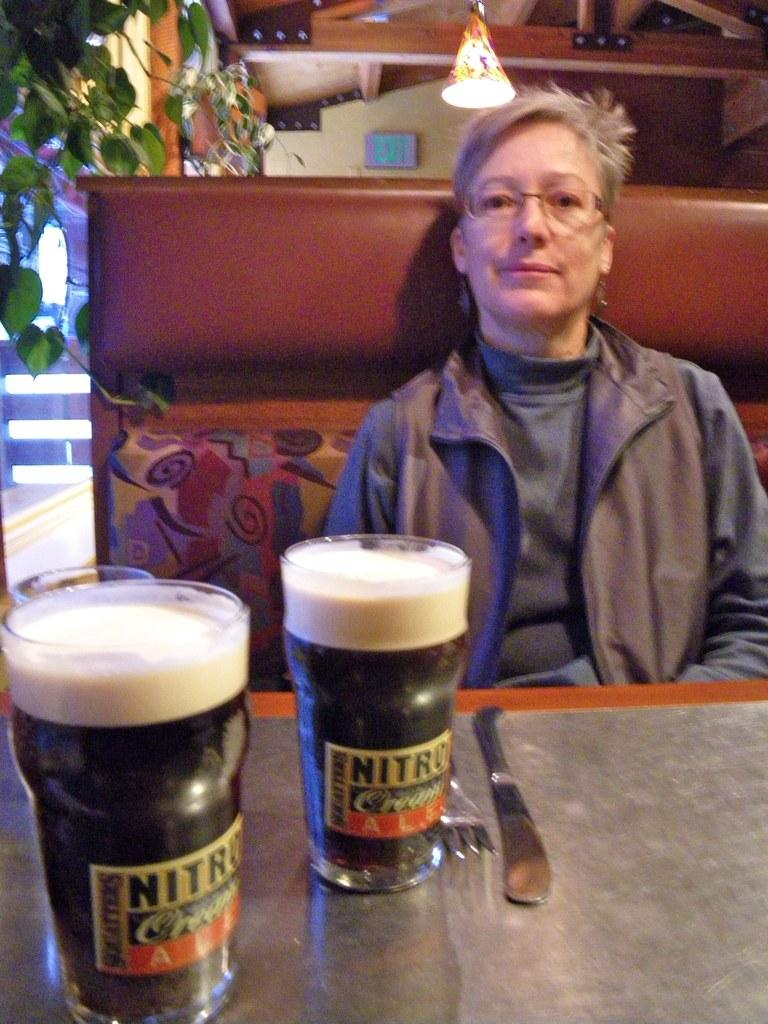<image>
Write a terse but informative summary of the picture. A woman sits a table in front of two Nitro Ale glasses 